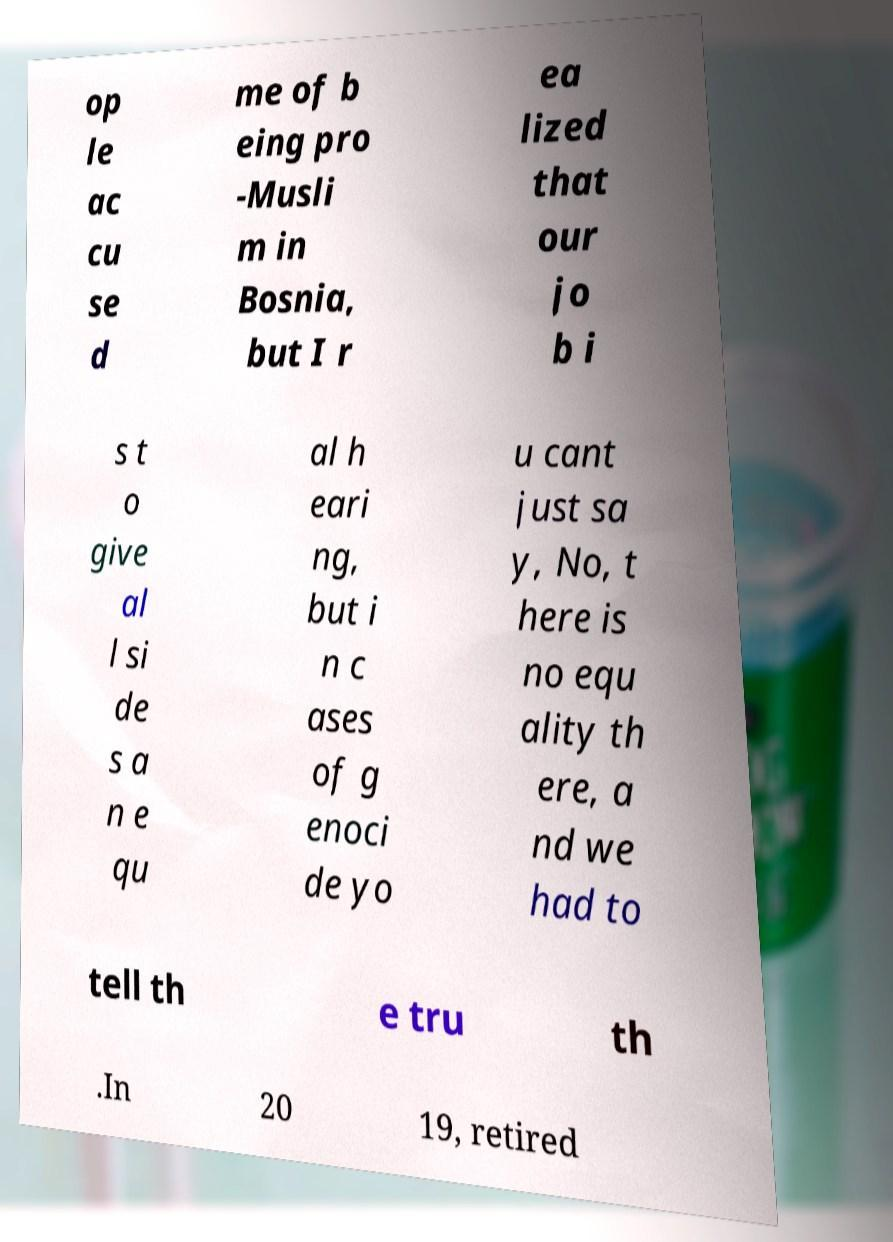Could you assist in decoding the text presented in this image and type it out clearly? op le ac cu se d me of b eing pro -Musli m in Bosnia, but I r ea lized that our jo b i s t o give al l si de s a n e qu al h eari ng, but i n c ases of g enoci de yo u cant just sa y, No, t here is no equ ality th ere, a nd we had to tell th e tru th .In 20 19, retired 